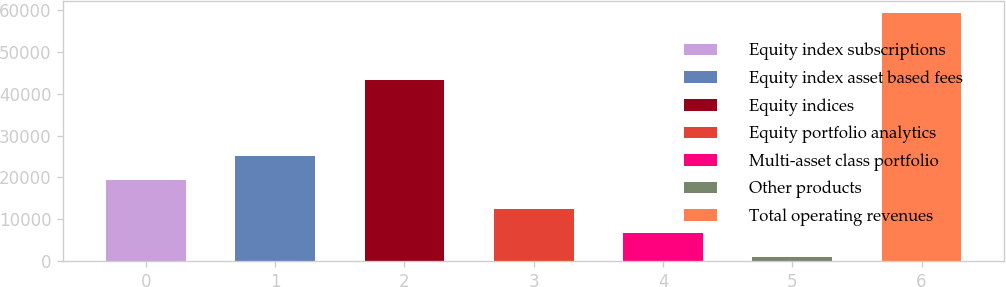Convert chart. <chart><loc_0><loc_0><loc_500><loc_500><bar_chart><fcel>Equity index subscriptions<fcel>Equity index asset based fees<fcel>Equity indices<fcel>Equity portfolio analytics<fcel>Multi-asset class portfolio<fcel>Other products<fcel>Total operating revenues<nl><fcel>19337<fcel>25168.8<fcel>43220<fcel>12533.6<fcel>6701.8<fcel>870<fcel>59188<nl></chart> 